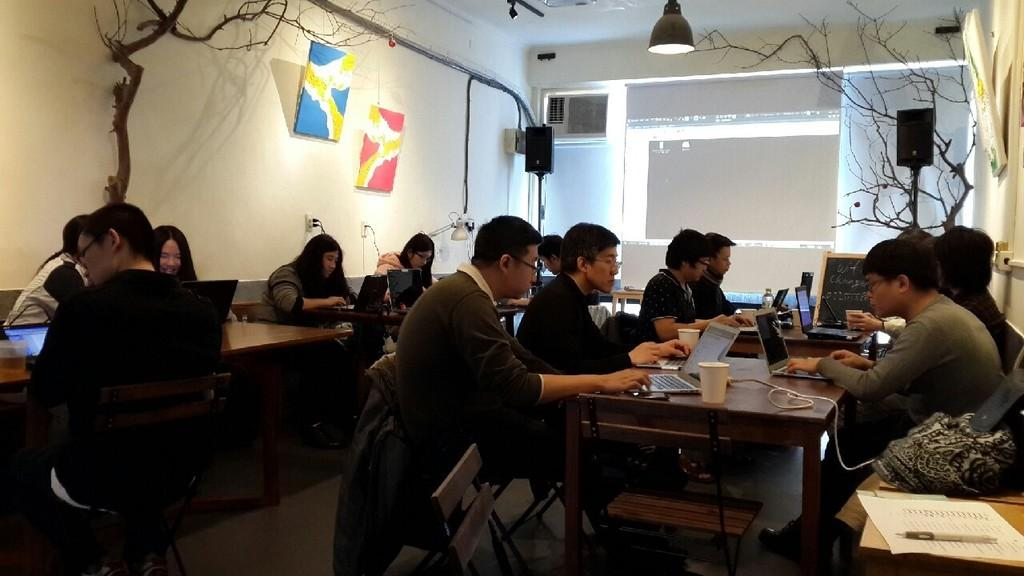What is the color of the wall in the image? The wall in the image is white. What type of tree can be seen in the image? There is a dry tree in the image. What items are present on the wall in the image? Photo frames are present in the image. What type of lighting is visible in the image? There is a light in the image. What are the people in the image doing? There are people sitting on chairs in the image. What electronic device is on the table in the image? There is a laptop on the table in the image. What type of glassware is on the table in the image? There is a glass on the table in the image. What type of container is on the table in the image? There is a bottle on the table in the image. How many fingers can be seen on the mice in the image? There are no mice present in the image, and therefore no fingers can be seen on them. What type of attraction is visible in the image? There is no attraction present in the image; it features a room with people, a laptop, and other objects. 